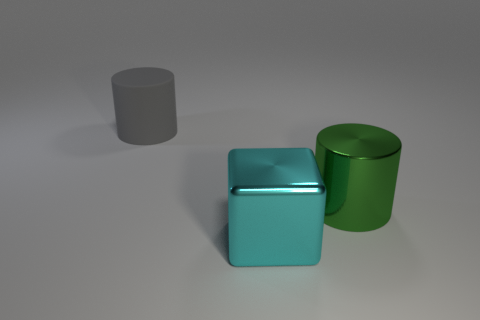What is the color of the metallic cylinder that is the same size as the gray matte thing?
Provide a succinct answer. Green. How many shiny objects are gray cylinders or cyan things?
Keep it short and to the point. 1. Are there an equal number of large blocks and tiny brown blocks?
Ensure brevity in your answer.  No. What number of cylinders are to the right of the large cyan metal block and to the left of the shiny cylinder?
Offer a very short reply. 0. Is there any other thing that has the same shape as the rubber thing?
Provide a succinct answer. Yes. How many other things are there of the same size as the gray rubber cylinder?
Keep it short and to the point. 2. Is the size of the cylinder that is right of the matte thing the same as the object that is in front of the large green metal cylinder?
Keep it short and to the point. Yes. What number of things are big green metal cylinders or large objects that are behind the cube?
Make the answer very short. 2. There is a cylinder in front of the matte cylinder; what is its size?
Provide a short and direct response. Large. Are there fewer big green metallic cylinders right of the big gray matte thing than big cyan cubes to the left of the large metallic block?
Give a very brief answer. No. 